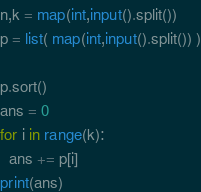<code> <loc_0><loc_0><loc_500><loc_500><_Python_>n,k = map(int,input().split())
p = list( map(int,input().split()) )

p.sort()
ans = 0
for i in range(k):
  ans += p[i]
print(ans)</code> 